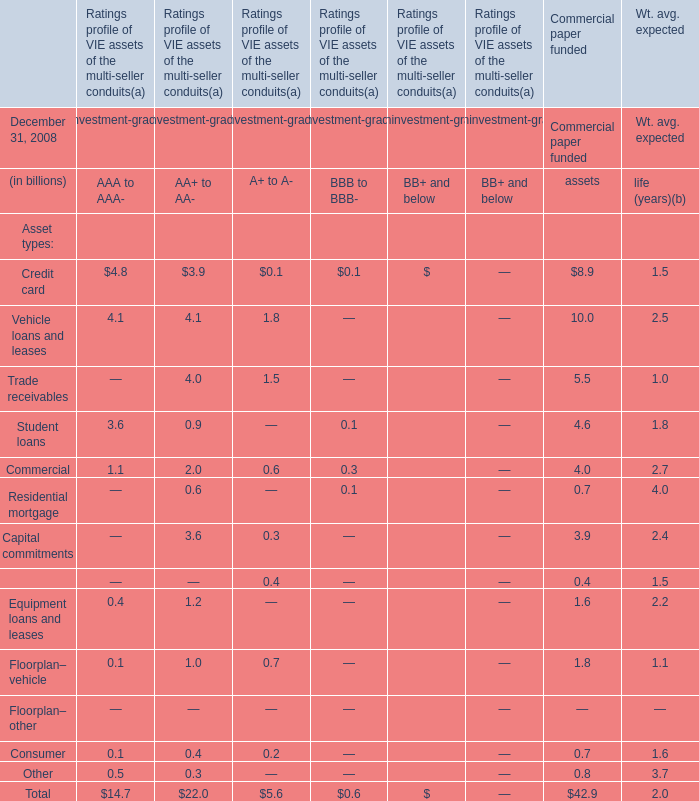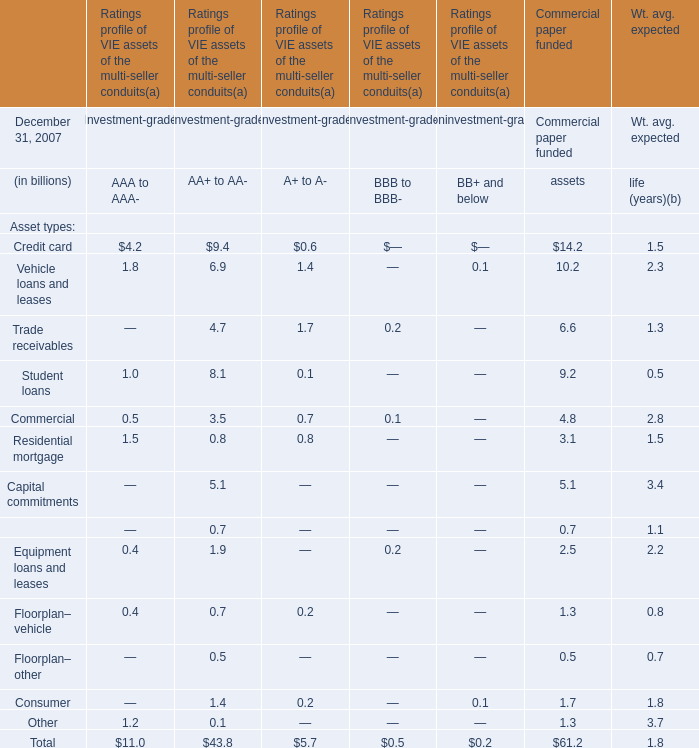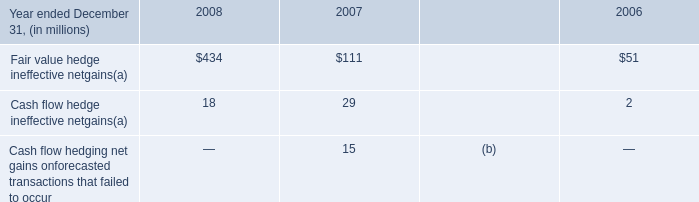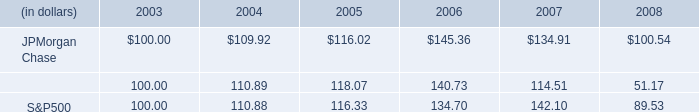in the retail segment , what is the average number of salespeople in each branch? 
Computations: (21400 / 5400)
Answer: 3.96296. 